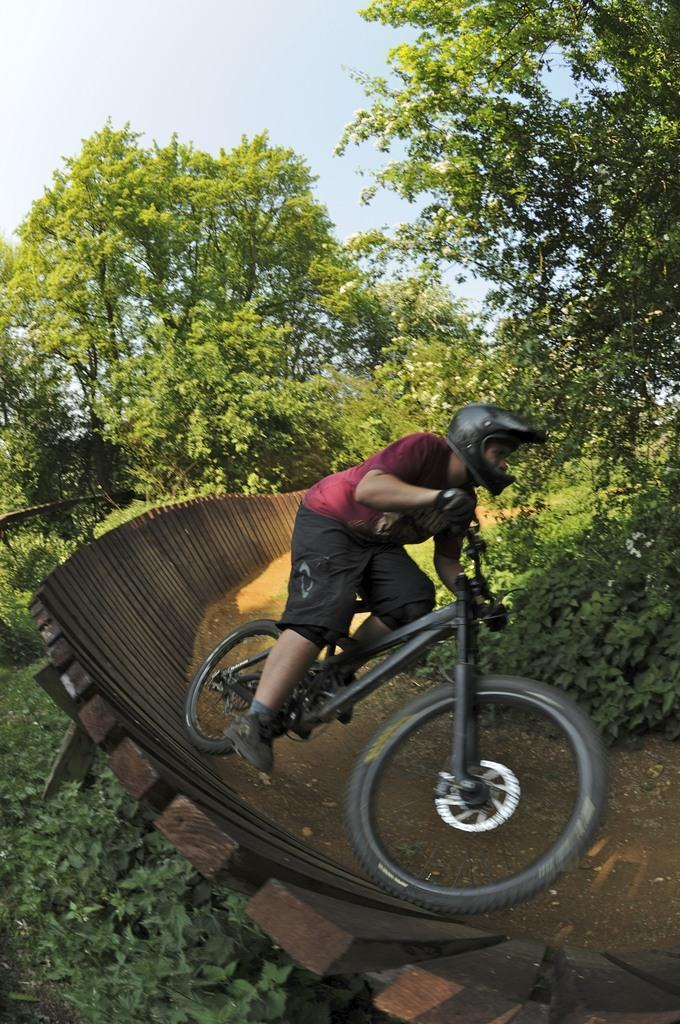What is the person in the image doing? The person is riding a cycle in the image. What safety precaution is the person taking while riding the cycle? The person is wearing a helmet. What can be seen in the background of the image? There are trees and the sky visible in the background of the image. What is the condition of the sky in the image? Clouds are present in the sky. How does the person fuel the cycle in the image? The image does not show the person fueling the cycle, as cycles are typically powered by human effort rather than fuel. What shape does the person ride the cycle in the image? The image does not indicate the shape in which the person is riding the cycle; it only shows the person riding it. 